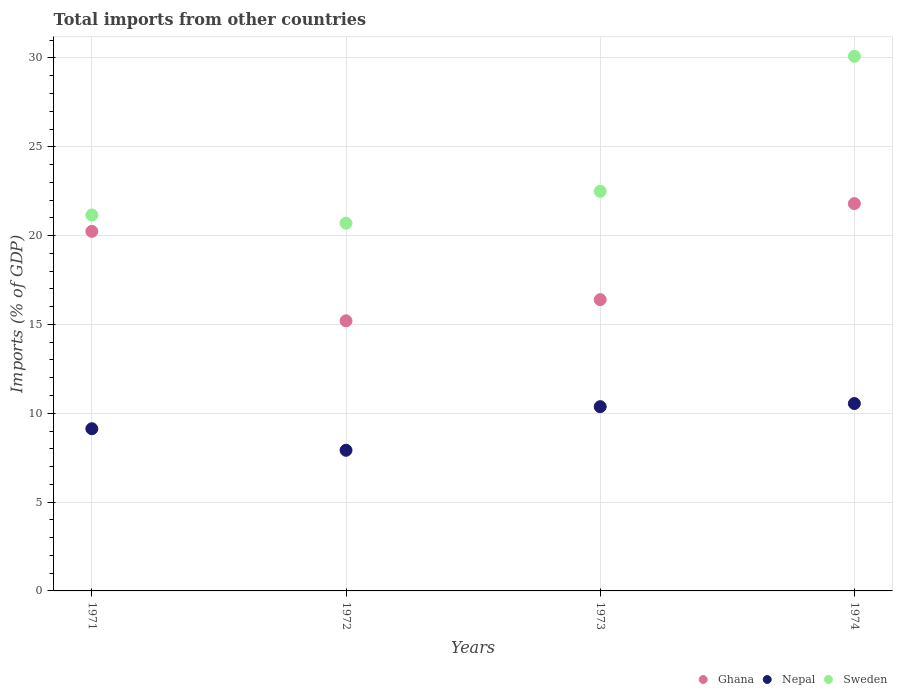What is the total imports in Sweden in 1972?
Your response must be concise. 20.7. Across all years, what is the maximum total imports in Nepal?
Make the answer very short. 10.55. Across all years, what is the minimum total imports in Ghana?
Provide a succinct answer. 15.2. In which year was the total imports in Ghana maximum?
Your answer should be compact. 1974. What is the total total imports in Ghana in the graph?
Your answer should be compact. 73.64. What is the difference between the total imports in Nepal in 1971 and that in 1972?
Your response must be concise. 1.21. What is the difference between the total imports in Ghana in 1973 and the total imports in Nepal in 1971?
Your response must be concise. 7.27. What is the average total imports in Ghana per year?
Offer a very short reply. 18.41. In the year 1971, what is the difference between the total imports in Nepal and total imports in Sweden?
Offer a terse response. -12.03. What is the ratio of the total imports in Ghana in 1971 to that in 1972?
Your answer should be compact. 1.33. Is the difference between the total imports in Nepal in 1973 and 1974 greater than the difference between the total imports in Sweden in 1973 and 1974?
Give a very brief answer. Yes. What is the difference between the highest and the second highest total imports in Nepal?
Your answer should be compact. 0.18. What is the difference between the highest and the lowest total imports in Sweden?
Your response must be concise. 9.4. In how many years, is the total imports in Ghana greater than the average total imports in Ghana taken over all years?
Your answer should be very brief. 2. Is the total imports in Ghana strictly greater than the total imports in Sweden over the years?
Provide a short and direct response. No. Is the total imports in Nepal strictly less than the total imports in Sweden over the years?
Give a very brief answer. Yes. How many dotlines are there?
Provide a short and direct response. 3. How many years are there in the graph?
Make the answer very short. 4. What is the difference between two consecutive major ticks on the Y-axis?
Give a very brief answer. 5. Are the values on the major ticks of Y-axis written in scientific E-notation?
Give a very brief answer. No. Does the graph contain grids?
Give a very brief answer. Yes. Where does the legend appear in the graph?
Your answer should be compact. Bottom right. How are the legend labels stacked?
Your answer should be compact. Horizontal. What is the title of the graph?
Give a very brief answer. Total imports from other countries. What is the label or title of the X-axis?
Your answer should be compact. Years. What is the label or title of the Y-axis?
Make the answer very short. Imports (% of GDP). What is the Imports (% of GDP) in Ghana in 1971?
Offer a very short reply. 20.24. What is the Imports (% of GDP) of Nepal in 1971?
Offer a very short reply. 9.13. What is the Imports (% of GDP) of Sweden in 1971?
Give a very brief answer. 21.16. What is the Imports (% of GDP) in Ghana in 1972?
Give a very brief answer. 15.2. What is the Imports (% of GDP) in Nepal in 1972?
Keep it short and to the point. 7.92. What is the Imports (% of GDP) in Sweden in 1972?
Your answer should be compact. 20.7. What is the Imports (% of GDP) of Ghana in 1973?
Your answer should be compact. 16.4. What is the Imports (% of GDP) in Nepal in 1973?
Provide a succinct answer. 10.37. What is the Imports (% of GDP) of Sweden in 1973?
Offer a terse response. 22.49. What is the Imports (% of GDP) in Ghana in 1974?
Your response must be concise. 21.8. What is the Imports (% of GDP) in Nepal in 1974?
Provide a succinct answer. 10.55. What is the Imports (% of GDP) in Sweden in 1974?
Your response must be concise. 30.1. Across all years, what is the maximum Imports (% of GDP) of Ghana?
Give a very brief answer. 21.8. Across all years, what is the maximum Imports (% of GDP) in Nepal?
Your answer should be compact. 10.55. Across all years, what is the maximum Imports (% of GDP) in Sweden?
Offer a terse response. 30.1. Across all years, what is the minimum Imports (% of GDP) of Ghana?
Give a very brief answer. 15.2. Across all years, what is the minimum Imports (% of GDP) in Nepal?
Offer a terse response. 7.92. Across all years, what is the minimum Imports (% of GDP) of Sweden?
Make the answer very short. 20.7. What is the total Imports (% of GDP) in Ghana in the graph?
Offer a very short reply. 73.64. What is the total Imports (% of GDP) in Nepal in the graph?
Your answer should be very brief. 37.97. What is the total Imports (% of GDP) of Sweden in the graph?
Offer a terse response. 94.45. What is the difference between the Imports (% of GDP) of Ghana in 1971 and that in 1972?
Provide a succinct answer. 5.04. What is the difference between the Imports (% of GDP) of Nepal in 1971 and that in 1972?
Your answer should be very brief. 1.21. What is the difference between the Imports (% of GDP) of Sweden in 1971 and that in 1972?
Keep it short and to the point. 0.46. What is the difference between the Imports (% of GDP) in Ghana in 1971 and that in 1973?
Give a very brief answer. 3.84. What is the difference between the Imports (% of GDP) in Nepal in 1971 and that in 1973?
Offer a very short reply. -1.24. What is the difference between the Imports (% of GDP) in Sweden in 1971 and that in 1973?
Make the answer very short. -1.33. What is the difference between the Imports (% of GDP) in Ghana in 1971 and that in 1974?
Make the answer very short. -1.56. What is the difference between the Imports (% of GDP) in Nepal in 1971 and that in 1974?
Offer a very short reply. -1.42. What is the difference between the Imports (% of GDP) in Sweden in 1971 and that in 1974?
Keep it short and to the point. -8.94. What is the difference between the Imports (% of GDP) of Ghana in 1972 and that in 1973?
Your response must be concise. -1.19. What is the difference between the Imports (% of GDP) in Nepal in 1972 and that in 1973?
Keep it short and to the point. -2.45. What is the difference between the Imports (% of GDP) in Sweden in 1972 and that in 1973?
Offer a terse response. -1.79. What is the difference between the Imports (% of GDP) of Ghana in 1972 and that in 1974?
Your response must be concise. -6.6. What is the difference between the Imports (% of GDP) in Nepal in 1972 and that in 1974?
Make the answer very short. -2.63. What is the difference between the Imports (% of GDP) in Sweden in 1972 and that in 1974?
Keep it short and to the point. -9.4. What is the difference between the Imports (% of GDP) in Ghana in 1973 and that in 1974?
Ensure brevity in your answer.  -5.41. What is the difference between the Imports (% of GDP) of Nepal in 1973 and that in 1974?
Your answer should be very brief. -0.18. What is the difference between the Imports (% of GDP) of Sweden in 1973 and that in 1974?
Your answer should be compact. -7.6. What is the difference between the Imports (% of GDP) in Ghana in 1971 and the Imports (% of GDP) in Nepal in 1972?
Offer a terse response. 12.32. What is the difference between the Imports (% of GDP) of Ghana in 1971 and the Imports (% of GDP) of Sweden in 1972?
Ensure brevity in your answer.  -0.46. What is the difference between the Imports (% of GDP) in Nepal in 1971 and the Imports (% of GDP) in Sweden in 1972?
Your response must be concise. -11.57. What is the difference between the Imports (% of GDP) in Ghana in 1971 and the Imports (% of GDP) in Nepal in 1973?
Your answer should be compact. 9.87. What is the difference between the Imports (% of GDP) in Ghana in 1971 and the Imports (% of GDP) in Sweden in 1973?
Your answer should be very brief. -2.25. What is the difference between the Imports (% of GDP) of Nepal in 1971 and the Imports (% of GDP) of Sweden in 1973?
Keep it short and to the point. -13.36. What is the difference between the Imports (% of GDP) of Ghana in 1971 and the Imports (% of GDP) of Nepal in 1974?
Your response must be concise. 9.69. What is the difference between the Imports (% of GDP) in Ghana in 1971 and the Imports (% of GDP) in Sweden in 1974?
Your answer should be very brief. -9.86. What is the difference between the Imports (% of GDP) in Nepal in 1971 and the Imports (% of GDP) in Sweden in 1974?
Make the answer very short. -20.97. What is the difference between the Imports (% of GDP) of Ghana in 1972 and the Imports (% of GDP) of Nepal in 1973?
Your answer should be compact. 4.83. What is the difference between the Imports (% of GDP) of Ghana in 1972 and the Imports (% of GDP) of Sweden in 1973?
Offer a very short reply. -7.29. What is the difference between the Imports (% of GDP) in Nepal in 1972 and the Imports (% of GDP) in Sweden in 1973?
Offer a very short reply. -14.58. What is the difference between the Imports (% of GDP) in Ghana in 1972 and the Imports (% of GDP) in Nepal in 1974?
Provide a succinct answer. 4.66. What is the difference between the Imports (% of GDP) in Ghana in 1972 and the Imports (% of GDP) in Sweden in 1974?
Give a very brief answer. -14.89. What is the difference between the Imports (% of GDP) of Nepal in 1972 and the Imports (% of GDP) of Sweden in 1974?
Offer a very short reply. -22.18. What is the difference between the Imports (% of GDP) of Ghana in 1973 and the Imports (% of GDP) of Nepal in 1974?
Provide a succinct answer. 5.85. What is the difference between the Imports (% of GDP) of Ghana in 1973 and the Imports (% of GDP) of Sweden in 1974?
Offer a terse response. -13.7. What is the difference between the Imports (% of GDP) in Nepal in 1973 and the Imports (% of GDP) in Sweden in 1974?
Offer a terse response. -19.72. What is the average Imports (% of GDP) of Ghana per year?
Your answer should be very brief. 18.41. What is the average Imports (% of GDP) of Nepal per year?
Offer a terse response. 9.49. What is the average Imports (% of GDP) of Sweden per year?
Ensure brevity in your answer.  23.61. In the year 1971, what is the difference between the Imports (% of GDP) of Ghana and Imports (% of GDP) of Nepal?
Give a very brief answer. 11.11. In the year 1971, what is the difference between the Imports (% of GDP) of Ghana and Imports (% of GDP) of Sweden?
Offer a very short reply. -0.92. In the year 1971, what is the difference between the Imports (% of GDP) of Nepal and Imports (% of GDP) of Sweden?
Ensure brevity in your answer.  -12.03. In the year 1972, what is the difference between the Imports (% of GDP) in Ghana and Imports (% of GDP) in Nepal?
Your answer should be compact. 7.29. In the year 1972, what is the difference between the Imports (% of GDP) of Ghana and Imports (% of GDP) of Sweden?
Give a very brief answer. -5.5. In the year 1972, what is the difference between the Imports (% of GDP) in Nepal and Imports (% of GDP) in Sweden?
Your answer should be compact. -12.78. In the year 1973, what is the difference between the Imports (% of GDP) in Ghana and Imports (% of GDP) in Nepal?
Provide a succinct answer. 6.02. In the year 1973, what is the difference between the Imports (% of GDP) in Ghana and Imports (% of GDP) in Sweden?
Offer a very short reply. -6.1. In the year 1973, what is the difference between the Imports (% of GDP) of Nepal and Imports (% of GDP) of Sweden?
Make the answer very short. -12.12. In the year 1974, what is the difference between the Imports (% of GDP) in Ghana and Imports (% of GDP) in Nepal?
Your answer should be very brief. 11.25. In the year 1974, what is the difference between the Imports (% of GDP) in Ghana and Imports (% of GDP) in Sweden?
Give a very brief answer. -8.29. In the year 1974, what is the difference between the Imports (% of GDP) of Nepal and Imports (% of GDP) of Sweden?
Provide a succinct answer. -19.55. What is the ratio of the Imports (% of GDP) of Ghana in 1971 to that in 1972?
Provide a short and direct response. 1.33. What is the ratio of the Imports (% of GDP) in Nepal in 1971 to that in 1972?
Provide a succinct answer. 1.15. What is the ratio of the Imports (% of GDP) of Sweden in 1971 to that in 1972?
Provide a succinct answer. 1.02. What is the ratio of the Imports (% of GDP) of Ghana in 1971 to that in 1973?
Ensure brevity in your answer.  1.23. What is the ratio of the Imports (% of GDP) in Nepal in 1971 to that in 1973?
Offer a terse response. 0.88. What is the ratio of the Imports (% of GDP) in Sweden in 1971 to that in 1973?
Ensure brevity in your answer.  0.94. What is the ratio of the Imports (% of GDP) of Ghana in 1971 to that in 1974?
Your response must be concise. 0.93. What is the ratio of the Imports (% of GDP) in Nepal in 1971 to that in 1974?
Give a very brief answer. 0.87. What is the ratio of the Imports (% of GDP) in Sweden in 1971 to that in 1974?
Your response must be concise. 0.7. What is the ratio of the Imports (% of GDP) of Ghana in 1972 to that in 1973?
Keep it short and to the point. 0.93. What is the ratio of the Imports (% of GDP) of Nepal in 1972 to that in 1973?
Give a very brief answer. 0.76. What is the ratio of the Imports (% of GDP) of Sweden in 1972 to that in 1973?
Keep it short and to the point. 0.92. What is the ratio of the Imports (% of GDP) of Ghana in 1972 to that in 1974?
Offer a very short reply. 0.7. What is the ratio of the Imports (% of GDP) of Nepal in 1972 to that in 1974?
Offer a terse response. 0.75. What is the ratio of the Imports (% of GDP) of Sweden in 1972 to that in 1974?
Keep it short and to the point. 0.69. What is the ratio of the Imports (% of GDP) in Ghana in 1973 to that in 1974?
Provide a short and direct response. 0.75. What is the ratio of the Imports (% of GDP) of Nepal in 1973 to that in 1974?
Offer a very short reply. 0.98. What is the ratio of the Imports (% of GDP) in Sweden in 1973 to that in 1974?
Offer a terse response. 0.75. What is the difference between the highest and the second highest Imports (% of GDP) of Ghana?
Keep it short and to the point. 1.56. What is the difference between the highest and the second highest Imports (% of GDP) in Nepal?
Provide a succinct answer. 0.18. What is the difference between the highest and the second highest Imports (% of GDP) in Sweden?
Offer a very short reply. 7.6. What is the difference between the highest and the lowest Imports (% of GDP) of Ghana?
Give a very brief answer. 6.6. What is the difference between the highest and the lowest Imports (% of GDP) of Nepal?
Keep it short and to the point. 2.63. What is the difference between the highest and the lowest Imports (% of GDP) in Sweden?
Keep it short and to the point. 9.4. 